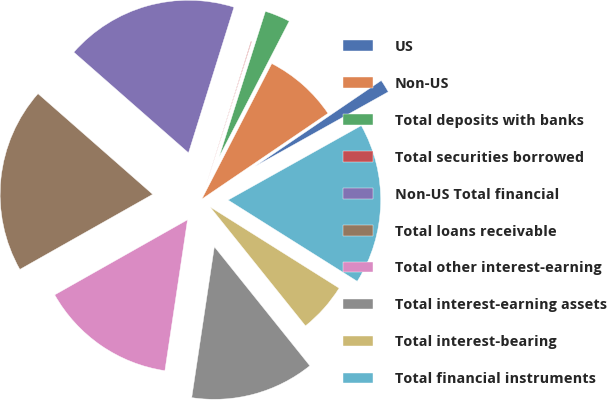Convert chart to OTSL. <chart><loc_0><loc_0><loc_500><loc_500><pie_chart><fcel>US<fcel>Non-US<fcel>Total deposits with banks<fcel>Total securities borrowed<fcel>Non-US Total financial<fcel>Total loans receivable<fcel>Total other interest-earning<fcel>Total interest-earning assets<fcel>Total interest-bearing<fcel>Total financial instruments<nl><fcel>1.39%<fcel>7.91%<fcel>2.69%<fcel>0.08%<fcel>18.35%<fcel>19.65%<fcel>14.44%<fcel>13.13%<fcel>5.3%<fcel>17.05%<nl></chart> 